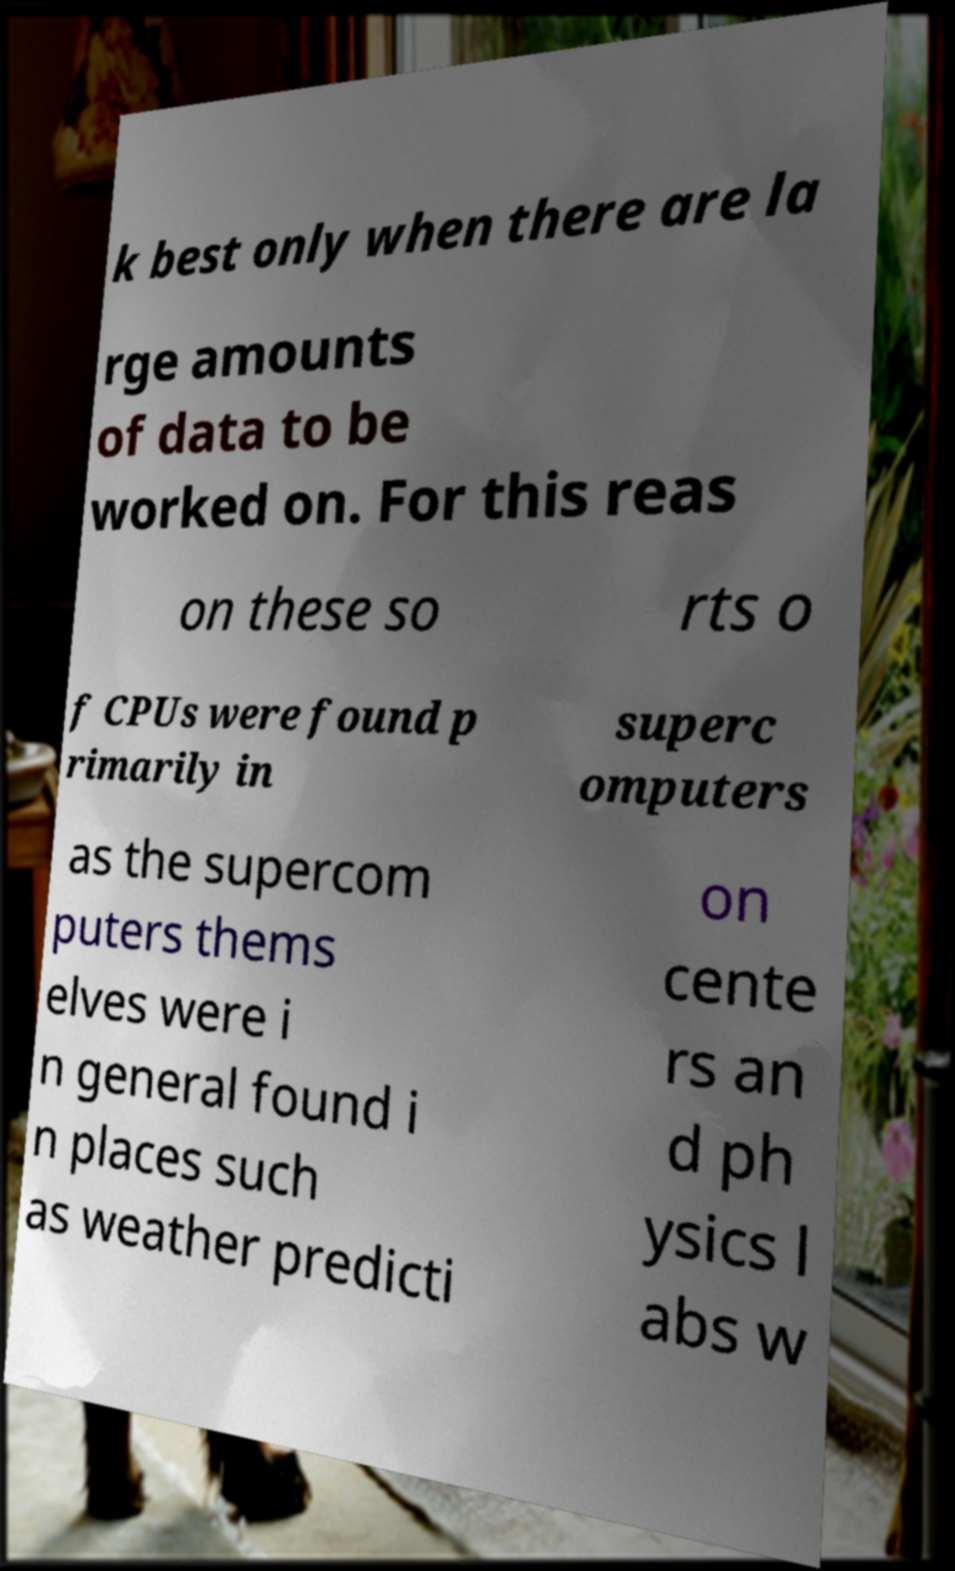Can you accurately transcribe the text from the provided image for me? k best only when there are la rge amounts of data to be worked on. For this reas on these so rts o f CPUs were found p rimarily in superc omputers as the supercom puters thems elves were i n general found i n places such as weather predicti on cente rs an d ph ysics l abs w 